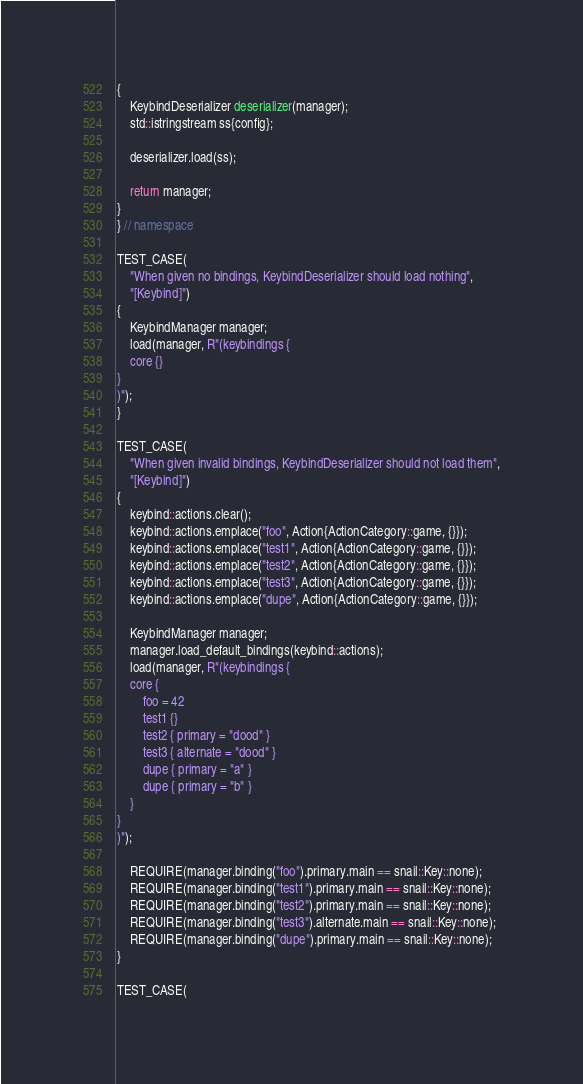<code> <loc_0><loc_0><loc_500><loc_500><_C++_>{
    KeybindDeserializer deserializer(manager);
    std::istringstream ss{config};

    deserializer.load(ss);

    return manager;
}
} // namespace

TEST_CASE(
    "When given no bindings, KeybindDeserializer should load nothing",
    "[Keybind]")
{
    KeybindManager manager;
    load(manager, R"(keybindings {
    core {}
}
)");
}

TEST_CASE(
    "When given invalid bindings, KeybindDeserializer should not load them",
    "[Keybind]")
{
    keybind::actions.clear();
    keybind::actions.emplace("foo", Action{ActionCategory::game, {}});
    keybind::actions.emplace("test1", Action{ActionCategory::game, {}});
    keybind::actions.emplace("test2", Action{ActionCategory::game, {}});
    keybind::actions.emplace("test3", Action{ActionCategory::game, {}});
    keybind::actions.emplace("dupe", Action{ActionCategory::game, {}});

    KeybindManager manager;
    manager.load_default_bindings(keybind::actions);
    load(manager, R"(keybindings {
    core {
        foo = 42
        test1 {}
        test2 { primary = "dood" }
        test3 { alternate = "dood" }
        dupe { primary = "a" }
        dupe { primary = "b" }
    }
}
)");

    REQUIRE(manager.binding("foo").primary.main == snail::Key::none);
    REQUIRE(manager.binding("test1").primary.main == snail::Key::none);
    REQUIRE(manager.binding("test2").primary.main == snail::Key::none);
    REQUIRE(manager.binding("test3").alternate.main == snail::Key::none);
    REQUIRE(manager.binding("dupe").primary.main == snail::Key::none);
}

TEST_CASE(</code> 